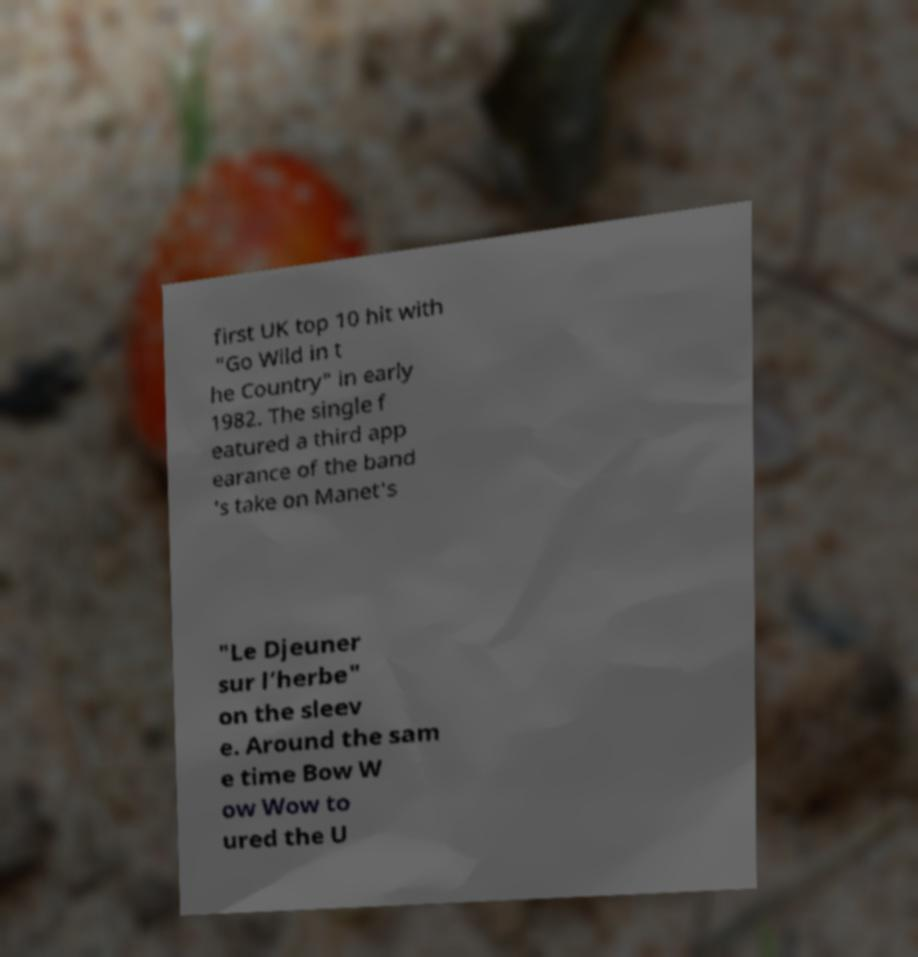I need the written content from this picture converted into text. Can you do that? first UK top 10 hit with "Go Wild in t he Country" in early 1982. The single f eatured a third app earance of the band 's take on Manet's "Le Djeuner sur l’herbe" on the sleev e. Around the sam e time Bow W ow Wow to ured the U 